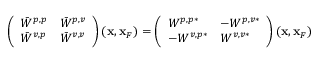Convert formula to latex. <formula><loc_0><loc_0><loc_500><loc_500>\begin{array} { r } { \left ( \begin{array} { l l } { \bar { W } ^ { p , p } } & { \bar { W } ^ { p , v } } \\ { \bar { W } ^ { v , p } } & { \bar { W } ^ { v , v } } \end{array} \right ) ( { x } , { x } _ { F } ) = \left ( \begin{array} { l l } { W ^ { p , p * } } & { - W ^ { p , v * } } \\ { - W ^ { v , p * } } & { W ^ { v , v * } } \end{array} \right ) ( { x } , { x } _ { F } ) } \end{array}</formula> 